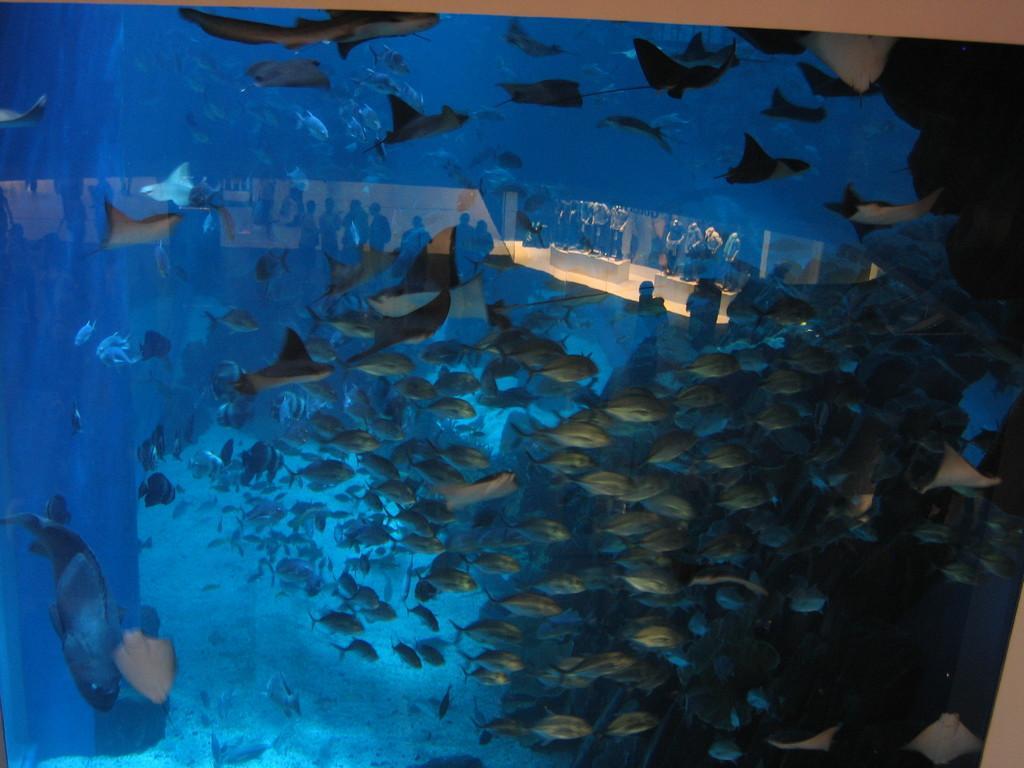Describe this image in one or two sentences. In this image there are so many fishes in the water. 